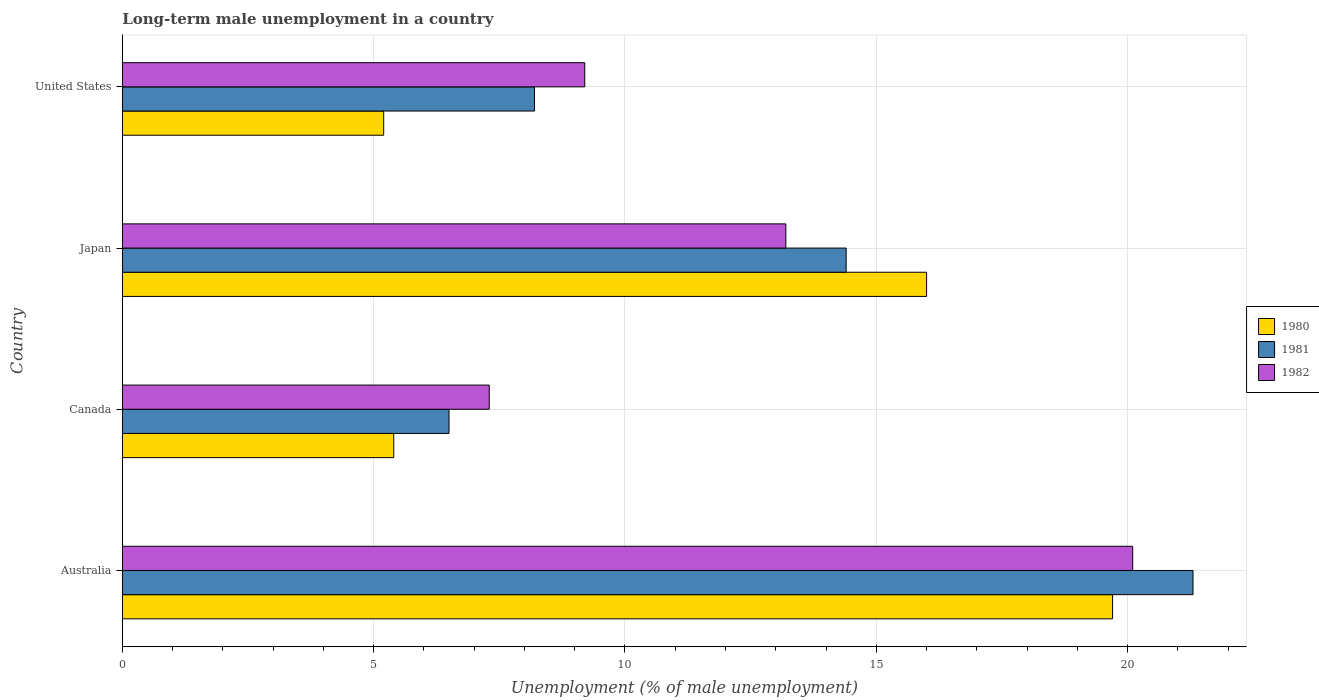Are the number of bars per tick equal to the number of legend labels?
Keep it short and to the point. Yes. How many bars are there on the 2nd tick from the top?
Provide a succinct answer. 3. What is the label of the 3rd group of bars from the top?
Ensure brevity in your answer.  Canada. What is the percentage of long-term unemployed male population in 1981 in Canada?
Ensure brevity in your answer.  6.5. Across all countries, what is the maximum percentage of long-term unemployed male population in 1980?
Give a very brief answer. 19.7. Across all countries, what is the minimum percentage of long-term unemployed male population in 1982?
Ensure brevity in your answer.  7.3. In which country was the percentage of long-term unemployed male population in 1981 maximum?
Give a very brief answer. Australia. What is the total percentage of long-term unemployed male population in 1982 in the graph?
Offer a terse response. 49.8. What is the difference between the percentage of long-term unemployed male population in 1982 in Canada and that in Japan?
Make the answer very short. -5.9. What is the difference between the percentage of long-term unemployed male population in 1982 in Canada and the percentage of long-term unemployed male population in 1980 in United States?
Your answer should be very brief. 2.1. What is the average percentage of long-term unemployed male population in 1982 per country?
Ensure brevity in your answer.  12.45. What is the difference between the percentage of long-term unemployed male population in 1980 and percentage of long-term unemployed male population in 1981 in Canada?
Ensure brevity in your answer.  -1.1. What is the ratio of the percentage of long-term unemployed male population in 1981 in Japan to that in United States?
Your answer should be very brief. 1.76. Is the percentage of long-term unemployed male population in 1980 in Australia less than that in Japan?
Provide a short and direct response. No. Is the difference between the percentage of long-term unemployed male population in 1980 in Canada and Japan greater than the difference between the percentage of long-term unemployed male population in 1981 in Canada and Japan?
Provide a succinct answer. No. What is the difference between the highest and the second highest percentage of long-term unemployed male population in 1982?
Give a very brief answer. 6.9. What is the difference between the highest and the lowest percentage of long-term unemployed male population in 1982?
Your response must be concise. 12.8. In how many countries, is the percentage of long-term unemployed male population in 1982 greater than the average percentage of long-term unemployed male population in 1982 taken over all countries?
Give a very brief answer. 2. Is the sum of the percentage of long-term unemployed male population in 1982 in Canada and United States greater than the maximum percentage of long-term unemployed male population in 1980 across all countries?
Your answer should be compact. No. Is it the case that in every country, the sum of the percentage of long-term unemployed male population in 1981 and percentage of long-term unemployed male population in 1982 is greater than the percentage of long-term unemployed male population in 1980?
Provide a succinct answer. Yes. Are all the bars in the graph horizontal?
Your answer should be very brief. Yes. Are the values on the major ticks of X-axis written in scientific E-notation?
Give a very brief answer. No. Does the graph contain grids?
Provide a succinct answer. Yes. Where does the legend appear in the graph?
Offer a very short reply. Center right. What is the title of the graph?
Your response must be concise. Long-term male unemployment in a country. What is the label or title of the X-axis?
Ensure brevity in your answer.  Unemployment (% of male unemployment). What is the label or title of the Y-axis?
Offer a terse response. Country. What is the Unemployment (% of male unemployment) of 1980 in Australia?
Your answer should be compact. 19.7. What is the Unemployment (% of male unemployment) in 1981 in Australia?
Keep it short and to the point. 21.3. What is the Unemployment (% of male unemployment) in 1982 in Australia?
Offer a terse response. 20.1. What is the Unemployment (% of male unemployment) in 1980 in Canada?
Give a very brief answer. 5.4. What is the Unemployment (% of male unemployment) in 1981 in Canada?
Give a very brief answer. 6.5. What is the Unemployment (% of male unemployment) of 1982 in Canada?
Ensure brevity in your answer.  7.3. What is the Unemployment (% of male unemployment) in 1980 in Japan?
Keep it short and to the point. 16. What is the Unemployment (% of male unemployment) of 1981 in Japan?
Make the answer very short. 14.4. What is the Unemployment (% of male unemployment) in 1982 in Japan?
Offer a very short reply. 13.2. What is the Unemployment (% of male unemployment) of 1980 in United States?
Make the answer very short. 5.2. What is the Unemployment (% of male unemployment) in 1981 in United States?
Offer a terse response. 8.2. What is the Unemployment (% of male unemployment) in 1982 in United States?
Your answer should be very brief. 9.2. Across all countries, what is the maximum Unemployment (% of male unemployment) in 1980?
Offer a terse response. 19.7. Across all countries, what is the maximum Unemployment (% of male unemployment) in 1981?
Keep it short and to the point. 21.3. Across all countries, what is the maximum Unemployment (% of male unemployment) in 1982?
Ensure brevity in your answer.  20.1. Across all countries, what is the minimum Unemployment (% of male unemployment) in 1980?
Your answer should be very brief. 5.2. Across all countries, what is the minimum Unemployment (% of male unemployment) of 1982?
Give a very brief answer. 7.3. What is the total Unemployment (% of male unemployment) of 1980 in the graph?
Ensure brevity in your answer.  46.3. What is the total Unemployment (% of male unemployment) in 1981 in the graph?
Your answer should be very brief. 50.4. What is the total Unemployment (% of male unemployment) of 1982 in the graph?
Give a very brief answer. 49.8. What is the difference between the Unemployment (% of male unemployment) in 1980 in Australia and that in United States?
Offer a terse response. 14.5. What is the difference between the Unemployment (% of male unemployment) in 1980 in Canada and that in United States?
Provide a succinct answer. 0.2. What is the difference between the Unemployment (% of male unemployment) in 1981 in Canada and that in United States?
Ensure brevity in your answer.  -1.7. What is the difference between the Unemployment (% of male unemployment) in 1982 in Canada and that in United States?
Your answer should be very brief. -1.9. What is the difference between the Unemployment (% of male unemployment) of 1980 in Japan and that in United States?
Provide a succinct answer. 10.8. What is the difference between the Unemployment (% of male unemployment) in 1982 in Japan and that in United States?
Keep it short and to the point. 4. What is the difference between the Unemployment (% of male unemployment) of 1980 in Australia and the Unemployment (% of male unemployment) of 1982 in Canada?
Make the answer very short. 12.4. What is the difference between the Unemployment (% of male unemployment) of 1980 in Australia and the Unemployment (% of male unemployment) of 1981 in United States?
Offer a very short reply. 11.5. What is the difference between the Unemployment (% of male unemployment) of 1980 in Australia and the Unemployment (% of male unemployment) of 1982 in United States?
Your response must be concise. 10.5. What is the difference between the Unemployment (% of male unemployment) of 1981 in Australia and the Unemployment (% of male unemployment) of 1982 in United States?
Give a very brief answer. 12.1. What is the difference between the Unemployment (% of male unemployment) of 1981 in Canada and the Unemployment (% of male unemployment) of 1982 in Japan?
Your response must be concise. -6.7. What is the difference between the Unemployment (% of male unemployment) of 1980 in Canada and the Unemployment (% of male unemployment) of 1982 in United States?
Offer a terse response. -3.8. What is the difference between the Unemployment (% of male unemployment) in 1981 in Canada and the Unemployment (% of male unemployment) in 1982 in United States?
Offer a very short reply. -2.7. What is the difference between the Unemployment (% of male unemployment) of 1980 in Japan and the Unemployment (% of male unemployment) of 1981 in United States?
Provide a succinct answer. 7.8. What is the difference between the Unemployment (% of male unemployment) of 1980 in Japan and the Unemployment (% of male unemployment) of 1982 in United States?
Give a very brief answer. 6.8. What is the average Unemployment (% of male unemployment) of 1980 per country?
Your response must be concise. 11.57. What is the average Unemployment (% of male unemployment) in 1982 per country?
Your response must be concise. 12.45. What is the difference between the Unemployment (% of male unemployment) of 1981 and Unemployment (% of male unemployment) of 1982 in Australia?
Keep it short and to the point. 1.2. What is the difference between the Unemployment (% of male unemployment) in 1980 and Unemployment (% of male unemployment) in 1981 in Canada?
Your answer should be compact. -1.1. What is the difference between the Unemployment (% of male unemployment) of 1980 and Unemployment (% of male unemployment) of 1982 in Canada?
Your answer should be very brief. -1.9. What is the difference between the Unemployment (% of male unemployment) in 1980 and Unemployment (% of male unemployment) in 1981 in Japan?
Offer a very short reply. 1.6. What is the difference between the Unemployment (% of male unemployment) of 1980 and Unemployment (% of male unemployment) of 1981 in United States?
Give a very brief answer. -3. What is the difference between the Unemployment (% of male unemployment) in 1981 and Unemployment (% of male unemployment) in 1982 in United States?
Your answer should be very brief. -1. What is the ratio of the Unemployment (% of male unemployment) in 1980 in Australia to that in Canada?
Provide a short and direct response. 3.65. What is the ratio of the Unemployment (% of male unemployment) of 1981 in Australia to that in Canada?
Provide a succinct answer. 3.28. What is the ratio of the Unemployment (% of male unemployment) in 1982 in Australia to that in Canada?
Make the answer very short. 2.75. What is the ratio of the Unemployment (% of male unemployment) of 1980 in Australia to that in Japan?
Provide a succinct answer. 1.23. What is the ratio of the Unemployment (% of male unemployment) of 1981 in Australia to that in Japan?
Give a very brief answer. 1.48. What is the ratio of the Unemployment (% of male unemployment) of 1982 in Australia to that in Japan?
Ensure brevity in your answer.  1.52. What is the ratio of the Unemployment (% of male unemployment) of 1980 in Australia to that in United States?
Offer a terse response. 3.79. What is the ratio of the Unemployment (% of male unemployment) in 1981 in Australia to that in United States?
Provide a short and direct response. 2.6. What is the ratio of the Unemployment (% of male unemployment) of 1982 in Australia to that in United States?
Keep it short and to the point. 2.18. What is the ratio of the Unemployment (% of male unemployment) in 1980 in Canada to that in Japan?
Offer a very short reply. 0.34. What is the ratio of the Unemployment (% of male unemployment) in 1981 in Canada to that in Japan?
Give a very brief answer. 0.45. What is the ratio of the Unemployment (% of male unemployment) in 1982 in Canada to that in Japan?
Your answer should be compact. 0.55. What is the ratio of the Unemployment (% of male unemployment) in 1981 in Canada to that in United States?
Keep it short and to the point. 0.79. What is the ratio of the Unemployment (% of male unemployment) of 1982 in Canada to that in United States?
Your response must be concise. 0.79. What is the ratio of the Unemployment (% of male unemployment) of 1980 in Japan to that in United States?
Give a very brief answer. 3.08. What is the ratio of the Unemployment (% of male unemployment) in 1981 in Japan to that in United States?
Offer a very short reply. 1.76. What is the ratio of the Unemployment (% of male unemployment) of 1982 in Japan to that in United States?
Keep it short and to the point. 1.43. What is the difference between the highest and the second highest Unemployment (% of male unemployment) of 1981?
Keep it short and to the point. 6.9. What is the difference between the highest and the second highest Unemployment (% of male unemployment) in 1982?
Your answer should be very brief. 6.9. 